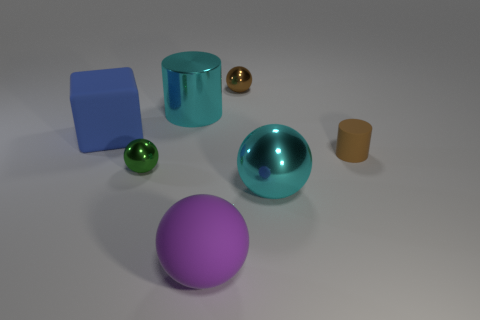Is there anything else that is the same shape as the blue object?
Your answer should be compact. No. There is a tiny brown thing that is to the left of the big shiny ball; does it have the same shape as the blue thing?
Keep it short and to the point. No. The big cylinder is what color?
Your answer should be compact. Cyan. Are there an equal number of tiny brown objects behind the large block and shiny balls that are left of the purple rubber thing?
Offer a terse response. Yes. What is the material of the tiny brown cylinder?
Provide a short and direct response. Rubber. What is the small ball on the right side of the cyan cylinder made of?
Provide a succinct answer. Metal. Are there more small objects that are left of the large cyan cylinder than big red cylinders?
Offer a very short reply. Yes. There is a large ball that is right of the sphere that is in front of the big cyan sphere; are there any brown objects to the right of it?
Provide a short and direct response. Yes. Are there any big blue matte objects to the right of the small green sphere?
Give a very brief answer. No. How many metal balls have the same color as the small matte thing?
Your answer should be very brief. 1. 